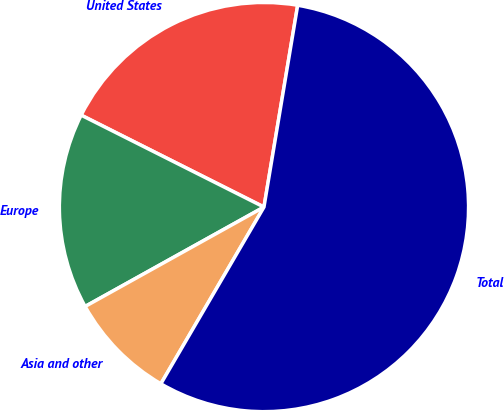Convert chart to OTSL. <chart><loc_0><loc_0><loc_500><loc_500><pie_chart><fcel>United States<fcel>Europe<fcel>Asia and other<fcel>Total<nl><fcel>20.22%<fcel>15.49%<fcel>8.52%<fcel>55.77%<nl></chart> 